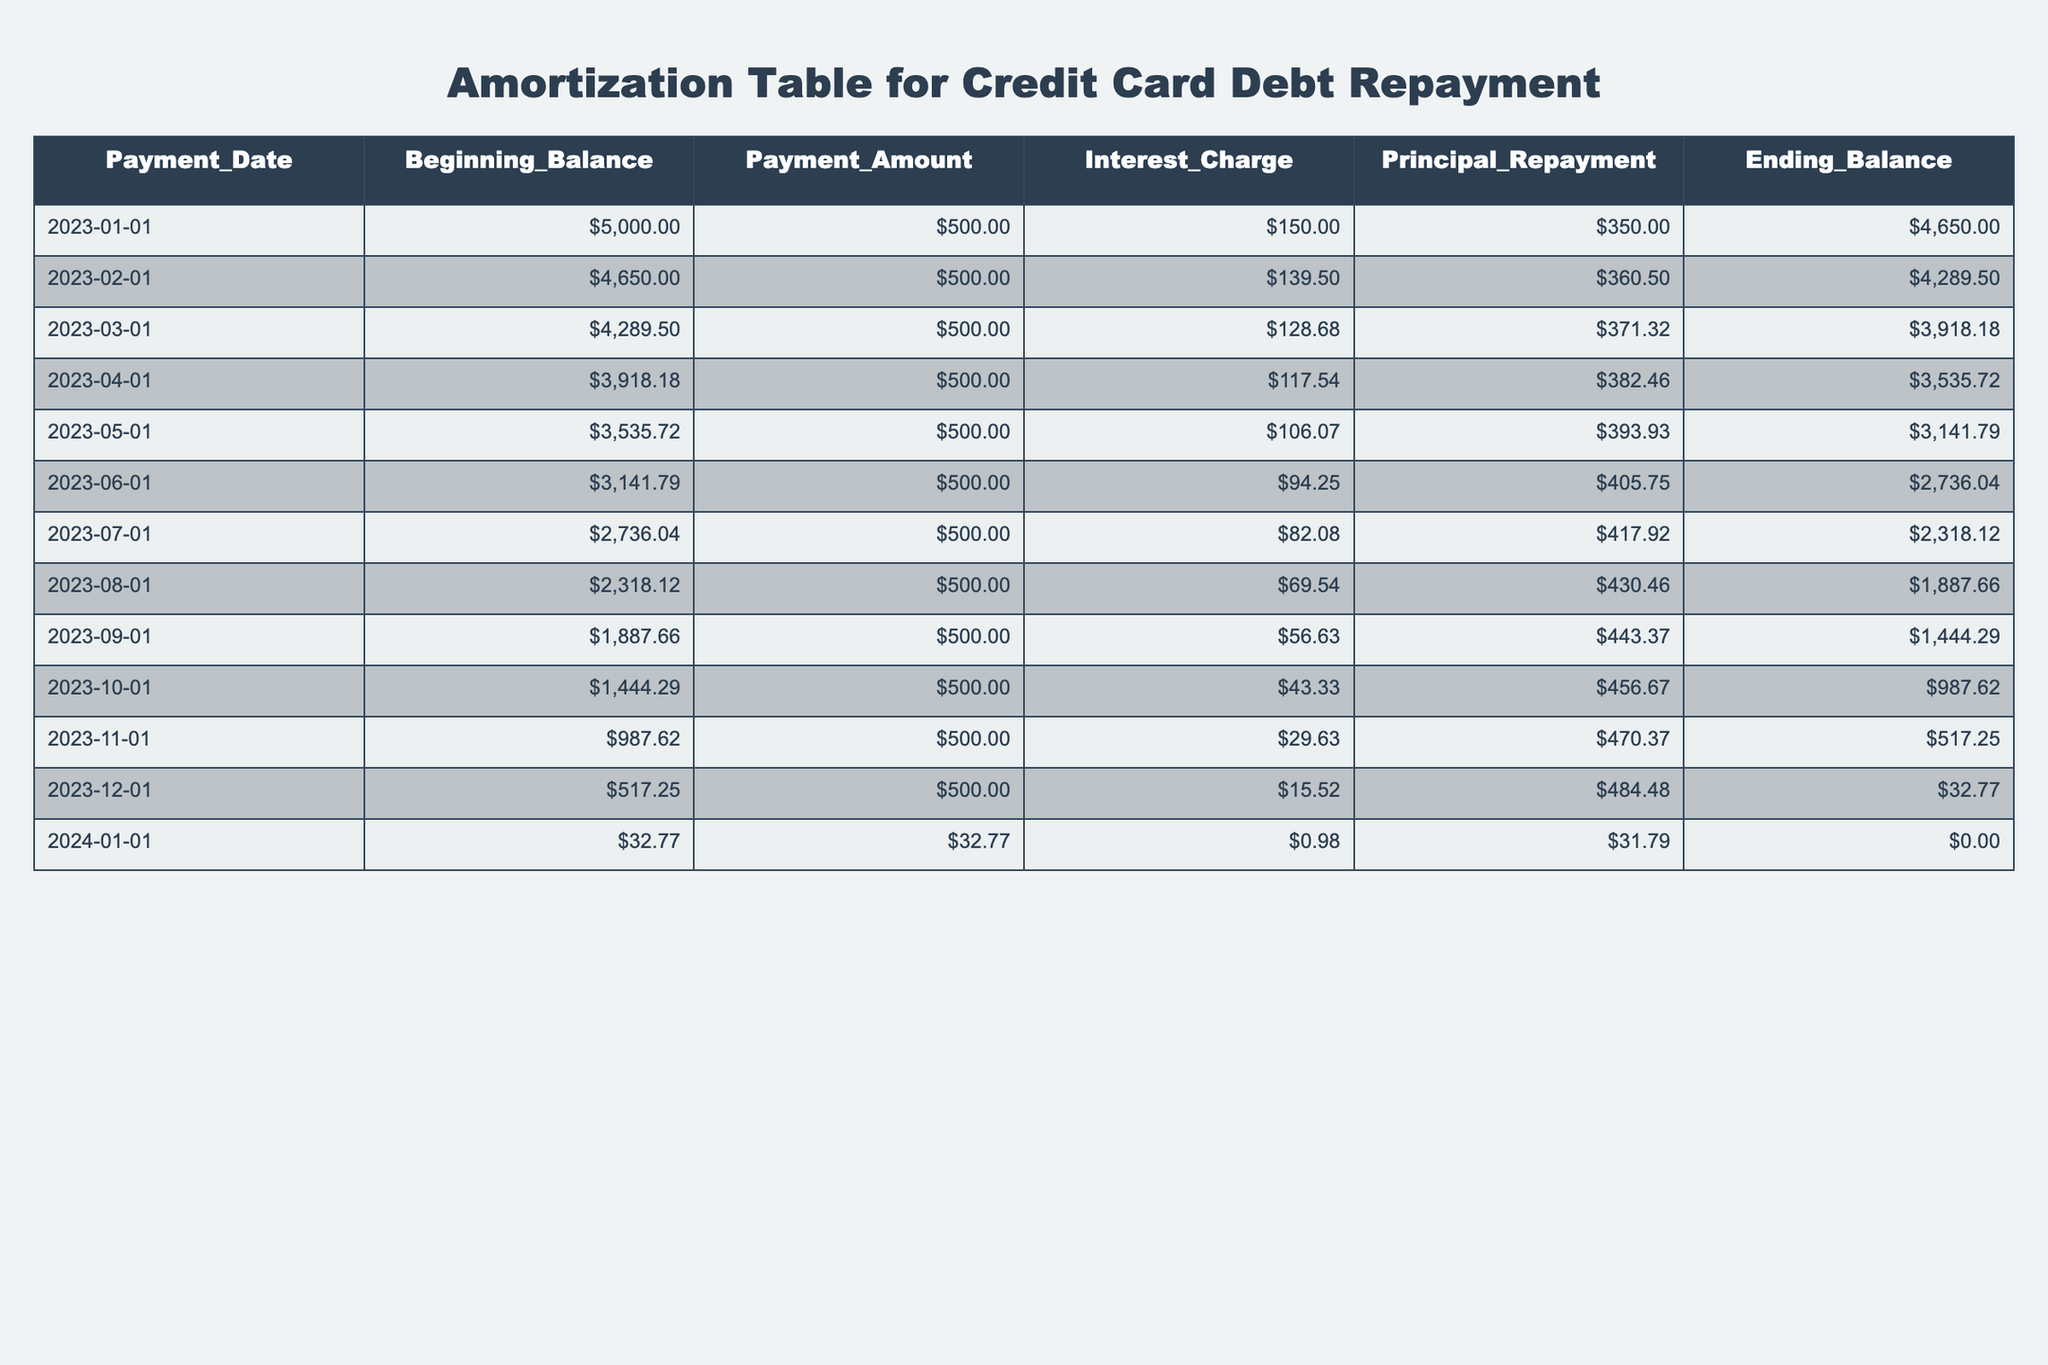What was the ending balance on March 1, 2023? The ending balance for March 1, 2023, is explicitly listed in the table for that payment date. It shows an ending balance of 3918.18.
Answer: 3918.18 How much was the principal repayment in May 2023? In the table, the principal repayment for May 2023 is found by looking at the row corresponding to that date. The amount listed is 393.93.
Answer: 393.93 What is the total interest charged from January to April 2023? To calculate the total interest charged from January to April 2023, we sum the interest charges from those months: 150.00 + 139.50 + 128.68 + 117.54 = 635.72.
Answer: 635.72 Did the payment amount exceed the interest charge in December 2023? In December 2023, the payment amount is 500.00, while the interest charge is 15.52. Since 500.00 is greater than 15.52, the answer is yes.
Answer: Yes In which month was the principal repayment the highest? To find the month with the highest principal repayment, we review the principal repayment amounts. The highest amount is in December 2023 with 484.48.
Answer: December 2023 What was the average ending balance for the second half of 2023 (July to December)? The ending balances for July to December are 2318.12, 1887.66, 1444.29, 987.62, 517.25, and 32.77. The average is calculated as (2318.12 + 1887.66 + 1444.29 + 987.62 + 517.25 + 32.77) / 6 = 1054.52.
Answer: 1054.52 How many months did it take to pay off the credit card debt completely? The last entry shows that by January 2024, the ending balance was 0.00, indicating the debt was paid off within 13 months (from January 2023 to January 2024).
Answer: 13 months What was the change in the ending balance from January to February 2023? To determine the change in the ending balance from January to February 2023, we subtract the February ending balance (4289.50) from the January ending balance (4650.00). The change is 4650.00 - 4289.50 = 360.50.
Answer: 360.50 Which month had the lowest beginning balance, and what was that amount? The beginning balance for January 2024 shows 32.77, which is the lowest when compared to all other monthly beginning balances.
Answer: January 2024, 32.77 